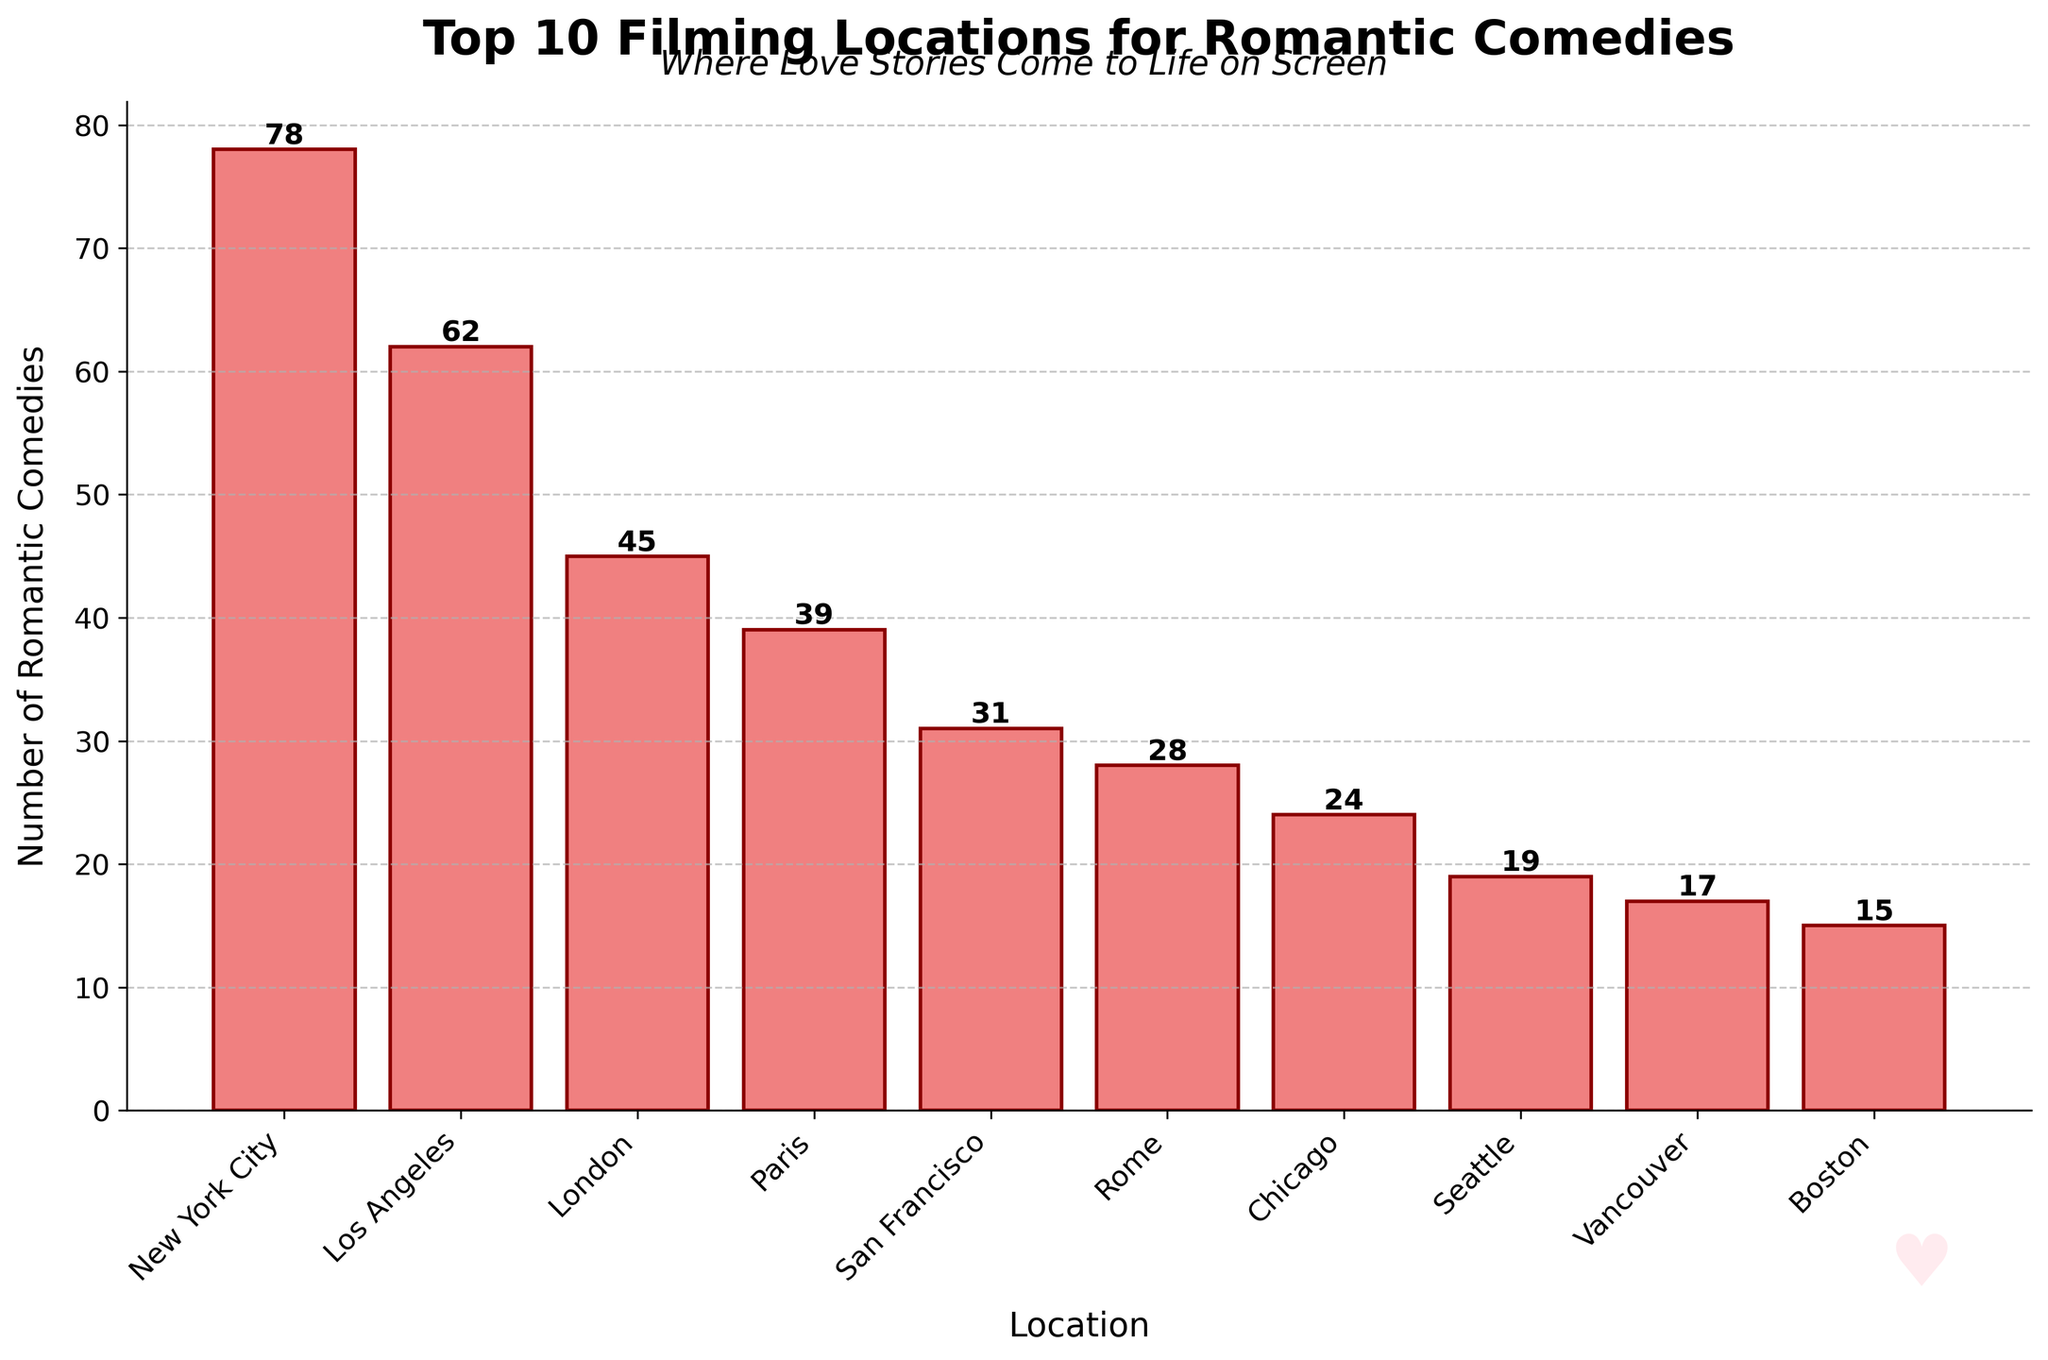Which location has the highest number of romantic comedies filmed? The location with the tallest bar in the chart is New York City, with a bar reaching up to 78 romantic comedies.
Answer: New York City How many more romantic comedies were filmed in New York City compared to Paris? The number of romantic comedies filmed in New York City is 78, while in Paris it's 39. Subtract Paris's number from New York City's number: 78 - 39 = 39.
Answer: 39 What is the total number of romantic comedies filmed in the top 3 locations? The number of romantic comedies in the top 3 locations are: New York City (78), Los Angeles (62), and London (45). Sum them up: 78 + 62 + 45 = 185.
Answer: 185 Which location has fewer romantic comedies filmed, San Francisco or Chicago? Comparing the bar heights, San Francisco has 31 and Chicago has 24. Since 24 is smaller, Chicago has fewer romantic comedies filmed.
Answer: Chicago What is the average number of romantic comedies filmed in the top 5 locations? The number of romantic comedies in the top 5 locations are: New York City (78), Los Angeles (62), London (45), Paris (39), and San Francisco (31). Sum these and then divide by 5: (78 + 62 + 45 + 39 + 31) / 5 = 51.
Answer: 51 Which location ranks 5th in the number of romantic comedies filmed? The 5th tallest bar represents the 5th ranked location, which is San Francisco with 31 romantic comedies.
Answer: San Francisco How many more romantic comedies were filmed in Los Angeles compared to Boston? Los Angeles has 62 and Boston has 15. Subtract Boston's number from Los Angeles's number: 62 - 15 = 47.
Answer: 47 Between Vancouver and Tokyo, which location filmed fewer romantic comedies, and by how many? Vancouver has 17 and Tokyo has 5. The difference is 17 - 5 = 12, with Tokyo having fewer romantic comedies.
Answer: Tokyo, 12 Which two locations have the same number of romantic comedies filmed? Examine the bar heights and identify that no two bars have the exact same height; therefore, no two locations have the same number of romantic comedies filmed.
Answer: None If you add the number of romantic comedies filmed in Rome and New Orleans, what do you get? Rome has 28, and New Orleans has 10. Sum them up: 28 + 10 = 38.
Answer: 38 